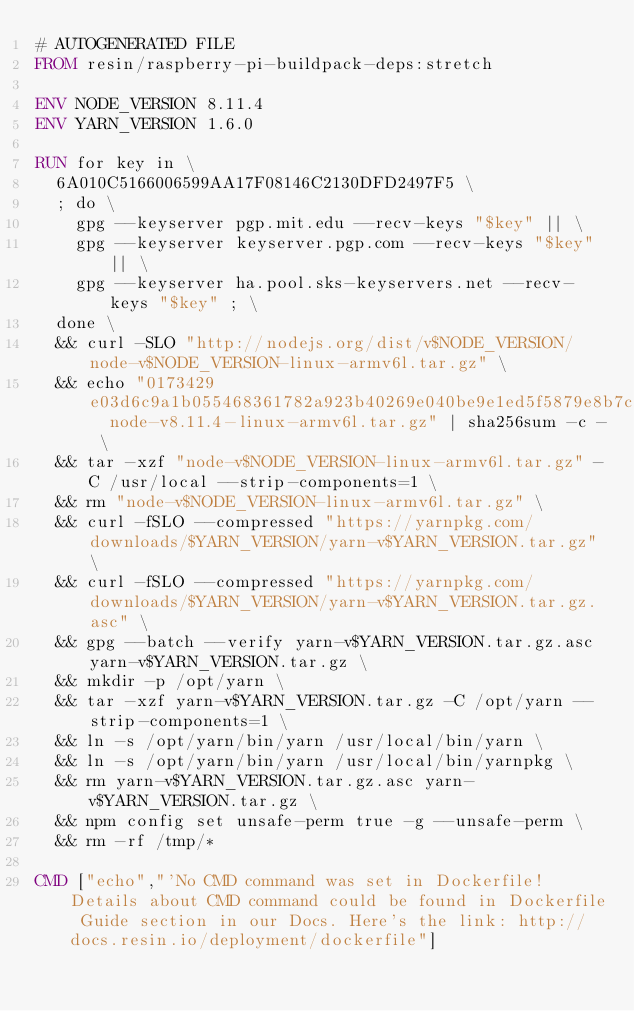Convert code to text. <code><loc_0><loc_0><loc_500><loc_500><_Dockerfile_># AUTOGENERATED FILE
FROM resin/raspberry-pi-buildpack-deps:stretch

ENV NODE_VERSION 8.11.4
ENV YARN_VERSION 1.6.0

RUN for key in \
	6A010C5166006599AA17F08146C2130DFD2497F5 \
	; do \
		gpg --keyserver pgp.mit.edu --recv-keys "$key" || \
		gpg --keyserver keyserver.pgp.com --recv-keys "$key" || \
		gpg --keyserver ha.pool.sks-keyservers.net --recv-keys "$key" ; \
	done \
	&& curl -SLO "http://nodejs.org/dist/v$NODE_VERSION/node-v$NODE_VERSION-linux-armv6l.tar.gz" \
	&& echo "0173429e03d6c9a1b055468361782a923b40269e040be9e1ed5f5879e8b7ccff  node-v8.11.4-linux-armv6l.tar.gz" | sha256sum -c - \
	&& tar -xzf "node-v$NODE_VERSION-linux-armv6l.tar.gz" -C /usr/local --strip-components=1 \
	&& rm "node-v$NODE_VERSION-linux-armv6l.tar.gz" \
	&& curl -fSLO --compressed "https://yarnpkg.com/downloads/$YARN_VERSION/yarn-v$YARN_VERSION.tar.gz" \
	&& curl -fSLO --compressed "https://yarnpkg.com/downloads/$YARN_VERSION/yarn-v$YARN_VERSION.tar.gz.asc" \
	&& gpg --batch --verify yarn-v$YARN_VERSION.tar.gz.asc yarn-v$YARN_VERSION.tar.gz \
	&& mkdir -p /opt/yarn \
	&& tar -xzf yarn-v$YARN_VERSION.tar.gz -C /opt/yarn --strip-components=1 \
	&& ln -s /opt/yarn/bin/yarn /usr/local/bin/yarn \
	&& ln -s /opt/yarn/bin/yarn /usr/local/bin/yarnpkg \
	&& rm yarn-v$YARN_VERSION.tar.gz.asc yarn-v$YARN_VERSION.tar.gz \
	&& npm config set unsafe-perm true -g --unsafe-perm \
	&& rm -rf /tmp/*

CMD ["echo","'No CMD command was set in Dockerfile! Details about CMD command could be found in Dockerfile Guide section in our Docs. Here's the link: http://docs.resin.io/deployment/dockerfile"]
</code> 